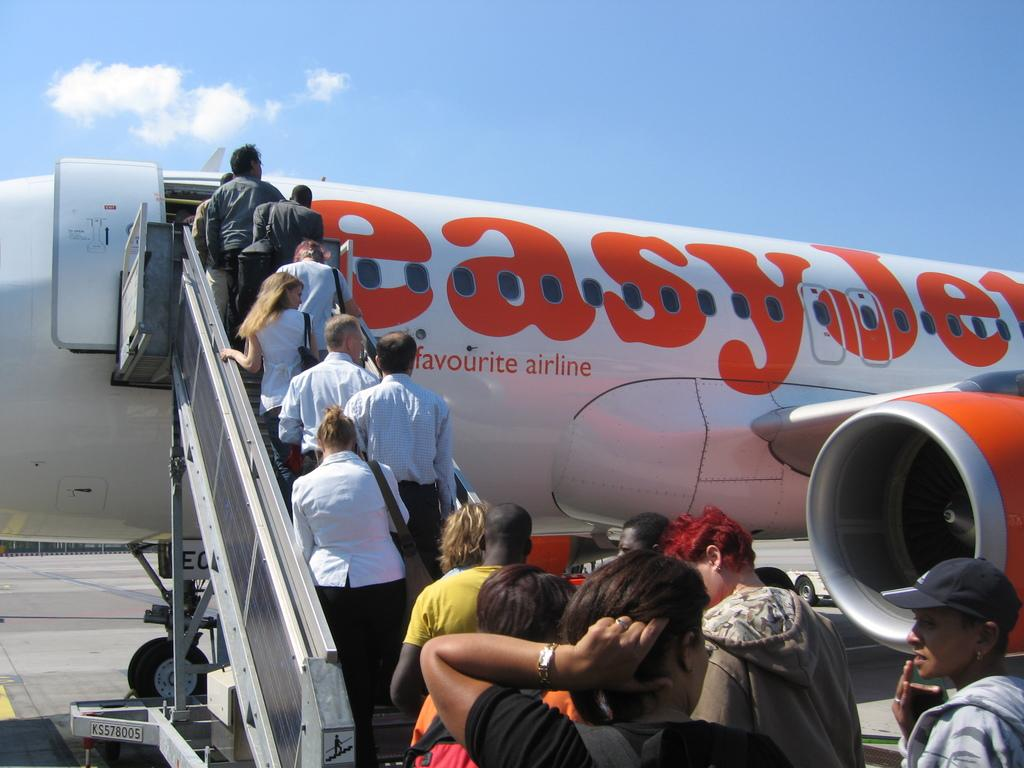<image>
Give a short and clear explanation of the subsequent image. Several people are boarding an easyJet plane outdoors. 